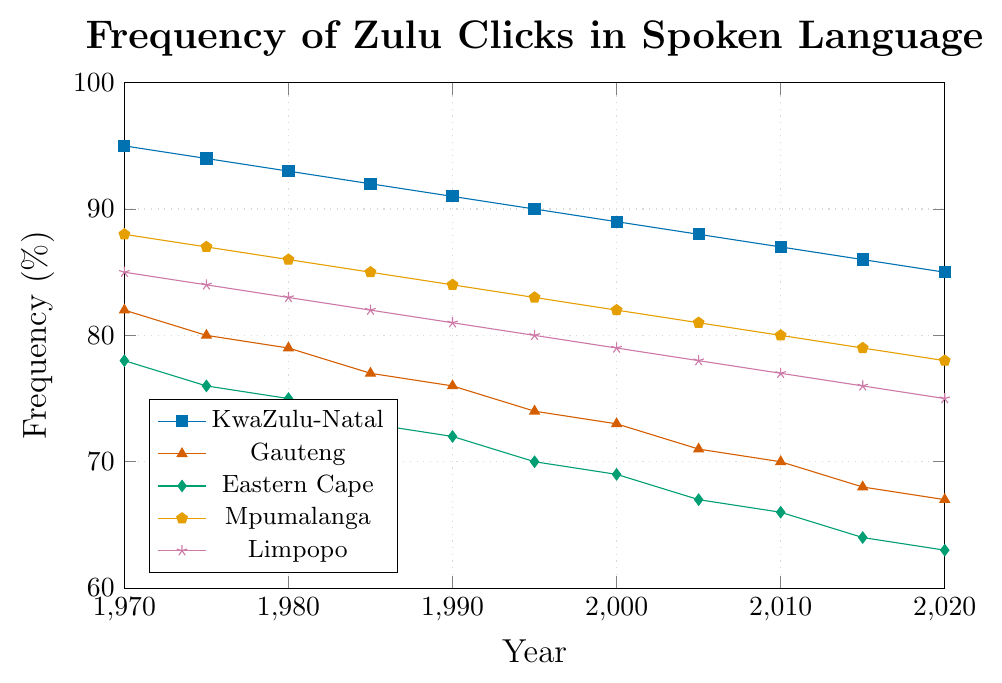How has the frequency of Zulu clicks changed in Mpumalanga from 1970 to 2020? The frequency dropped from 88% in 1970 to 78% in 2020.
Answer: It decreased by 10% Which region had the highest frequency of Zulu clicks in 2010? Comparing the values for 2010 (87% in KwaZulu-Natal, 70% in Gauteng, 66% in Eastern Cape, 80% in Mpumalanga, 77% in Limpopo), KwaZulu-Natal had the highest frequency.
Answer: KwaZulu-Natal What is the difference in the frequency of Zulu clicks between Gauteng and Eastern Cape in 2005? In 2005, Gauteng had a frequency of 71% and Eastern Cape had 67%. The difference is 71% - 67% = 4%.
Answer: 4% Which region had the smallest decrease in the frequency of Zulu clicks from 1970 to 2020? Calculate the decrease for each region: KwaZulu-Natal (95% to 85%, 10% decrease), Gauteng (82% to 67%, 15% decrease), Eastern Cape (78% to 63%, 15% decrease), Mpumalanga (88% to 78%, 10% decrease), Limpopo (85% to 75%, 10% decrease). The smallest decrease is 10%, which occurred in KwaZulu-Natal, Mpumalanga, and Limpopo.
Answer: KwaZulu-Natal, Mpumalanga, and Limpopo In what year did KwaZulu-Natal's frequency of Zulu clicks drop below 90%? Checking the values over the years, the frequency was 90% in 1995 and dropped to 89% in 2000.
Answer: 2000 Which region had the second highest frequency of Zulu clicks in 1975? Comparing the values for 1975 (95% in KwaZulu-Natal, 80% in Gauteng, 76% in Eastern Cape, 87% in Mpumalanga, 84% in Limpopo), Limpopo had the second highest frequency.
Answer: Limpopo On average, what was the frequency of Zulu clicks in Eastern Cape from 1970 to 2020? Adding up the frequencies for Eastern Cape (78, 76, 75, 73, 72, 70, 69, 67, 66, 64, 63) gives 803. Dividing by the number of data points (11) gives an average of 803/11 ≈ 73%.
Answer: 73% Which region shows a consistent decrease in the frequency of Zulu clicks over the years? Checking the values for all regions, KwaZulu-Natal (95% to 85%), Gauteng (82% to 67%), Eastern Cape (78% to 63%), Mpumalanga (88% to 78%), Limpopo (85% to 75%) all show consistent decreases over the years.
Answer: KwaZulu-Natal, Gauteng, Eastern Cape, Mpumalanga, Limpopo 